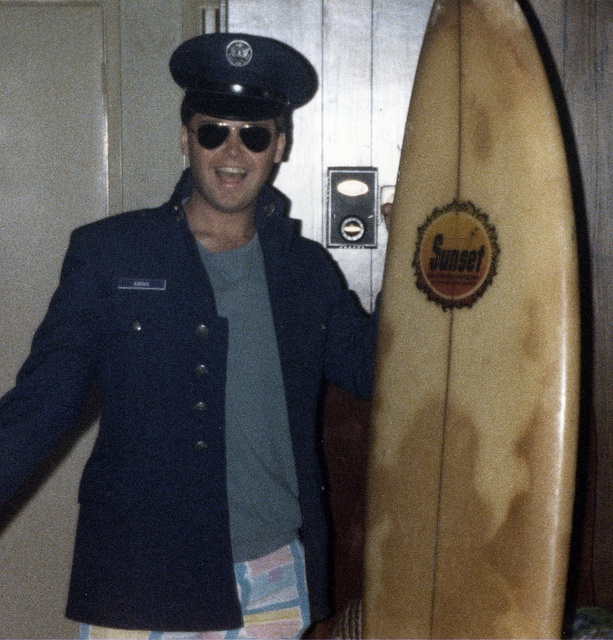Describe the objects in this image and their specific colors. I can see people in gray, black, and blue tones and surfboard in gray and tan tones in this image. 